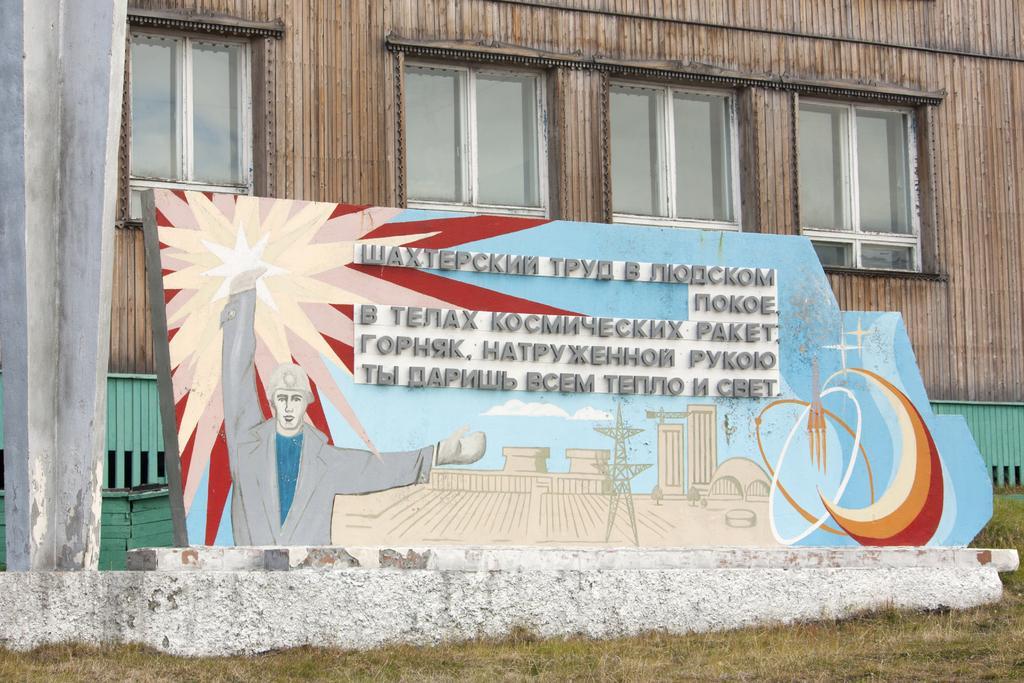In one or two sentences, can you explain what this image depicts? In this image I can see the grass. I can see a board with some text written on it. In the background, I can see a building with the windows. 